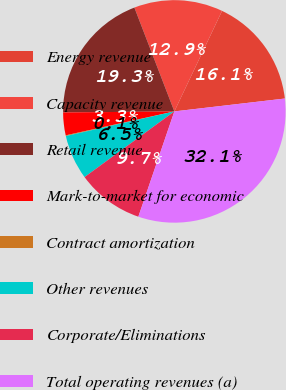<chart> <loc_0><loc_0><loc_500><loc_500><pie_chart><fcel>Energy revenue<fcel>Capacity revenue<fcel>Retail revenue<fcel>Mark-to-market for economic<fcel>Contract amortization<fcel>Other revenues<fcel>Corporate/Eliminations<fcel>Total operating revenues (a)<nl><fcel>16.1%<fcel>12.9%<fcel>19.3%<fcel>3.3%<fcel>0.1%<fcel>6.5%<fcel>9.7%<fcel>32.09%<nl></chart> 